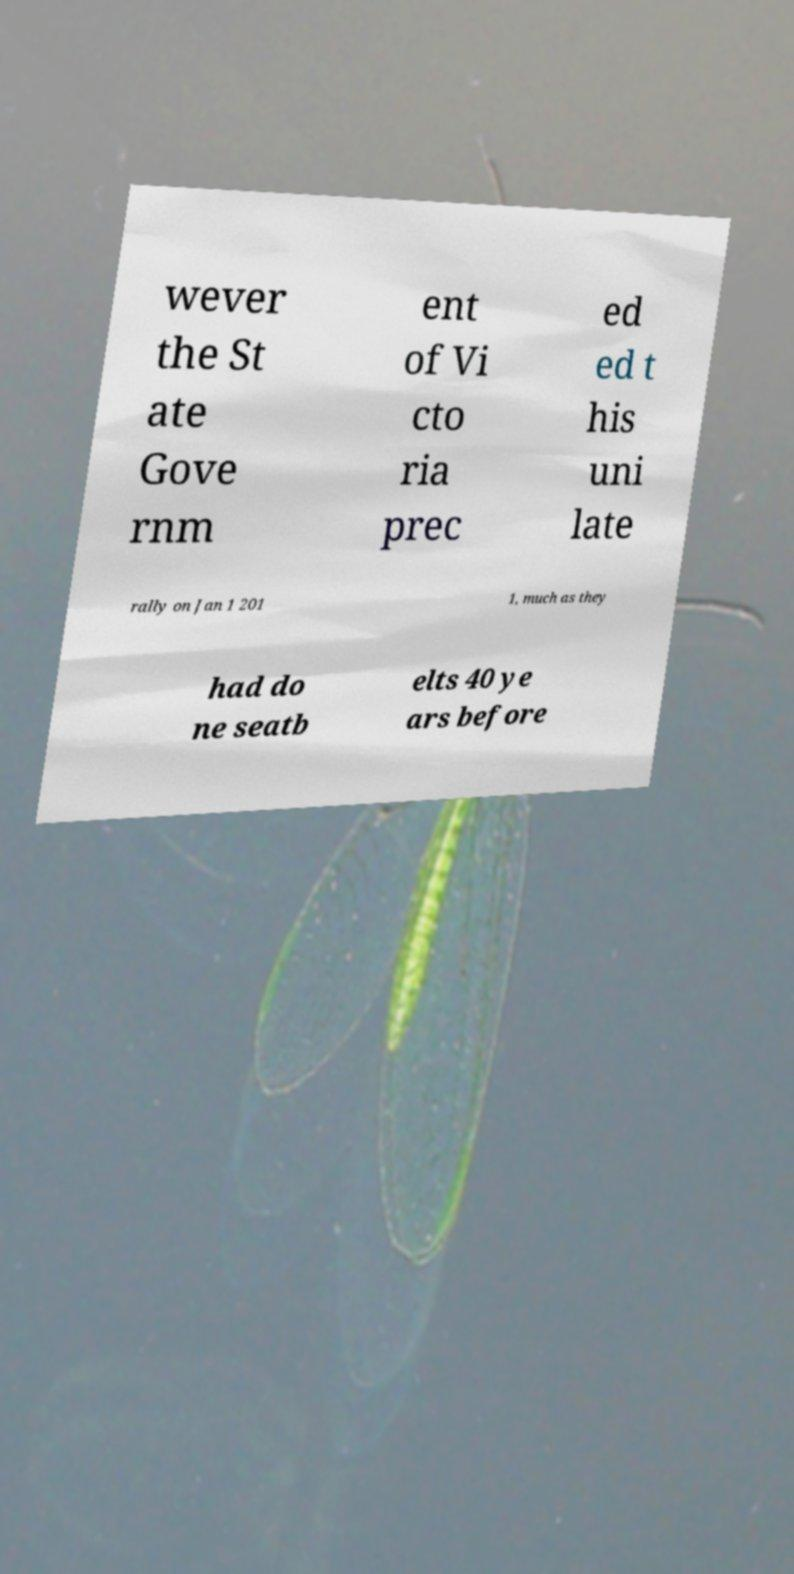Could you assist in decoding the text presented in this image and type it out clearly? wever the St ate Gove rnm ent of Vi cto ria prec ed ed t his uni late rally on Jan 1 201 1, much as they had do ne seatb elts 40 ye ars before 